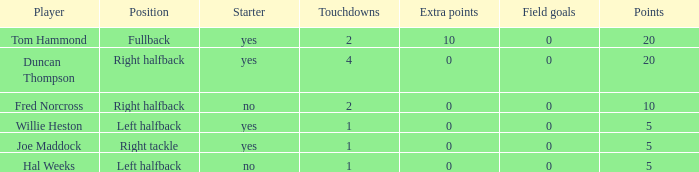How many field goals did duncan thompson have? 0.0. 